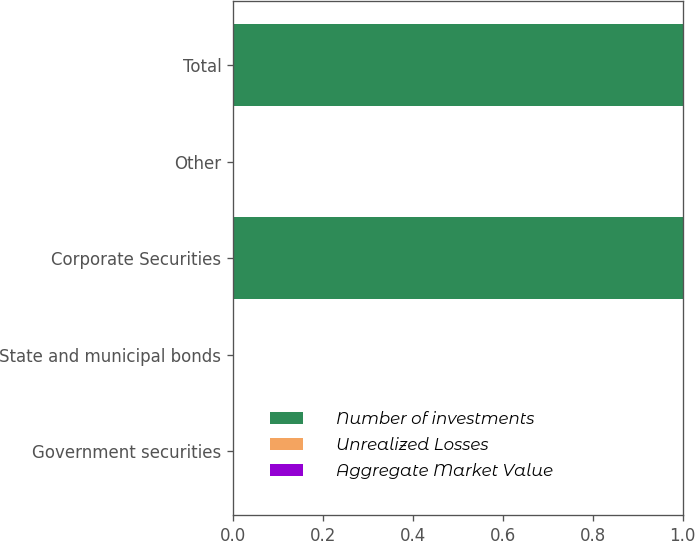Convert chart. <chart><loc_0><loc_0><loc_500><loc_500><stacked_bar_chart><ecel><fcel>Government securities<fcel>State and municipal bonds<fcel>Corporate Securities<fcel>Other<fcel>Total<nl><fcel>Number of investments<fcel>0<fcel>0<fcel>1<fcel>0<fcel>1<nl><fcel>Unrealized Losses<fcel>0<fcel>0<fcel>0<fcel>0<fcel>0<nl><fcel>Aggregate Market Value<fcel>0<fcel>0<fcel>0<fcel>0<fcel>0<nl></chart> 